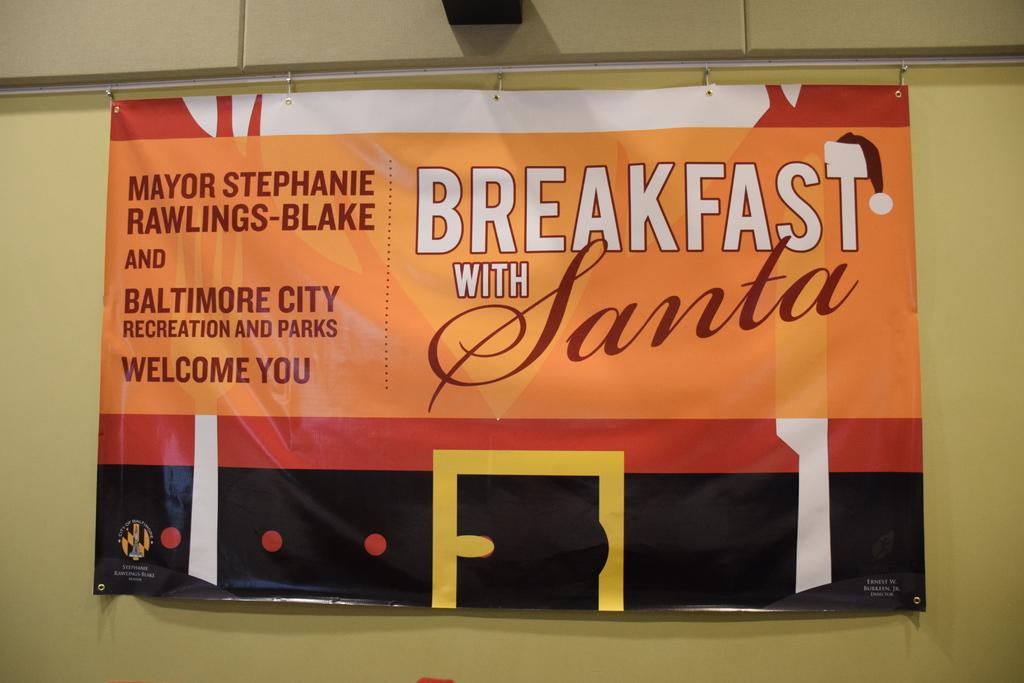Breakfast with who?
Offer a terse response. Santa. 